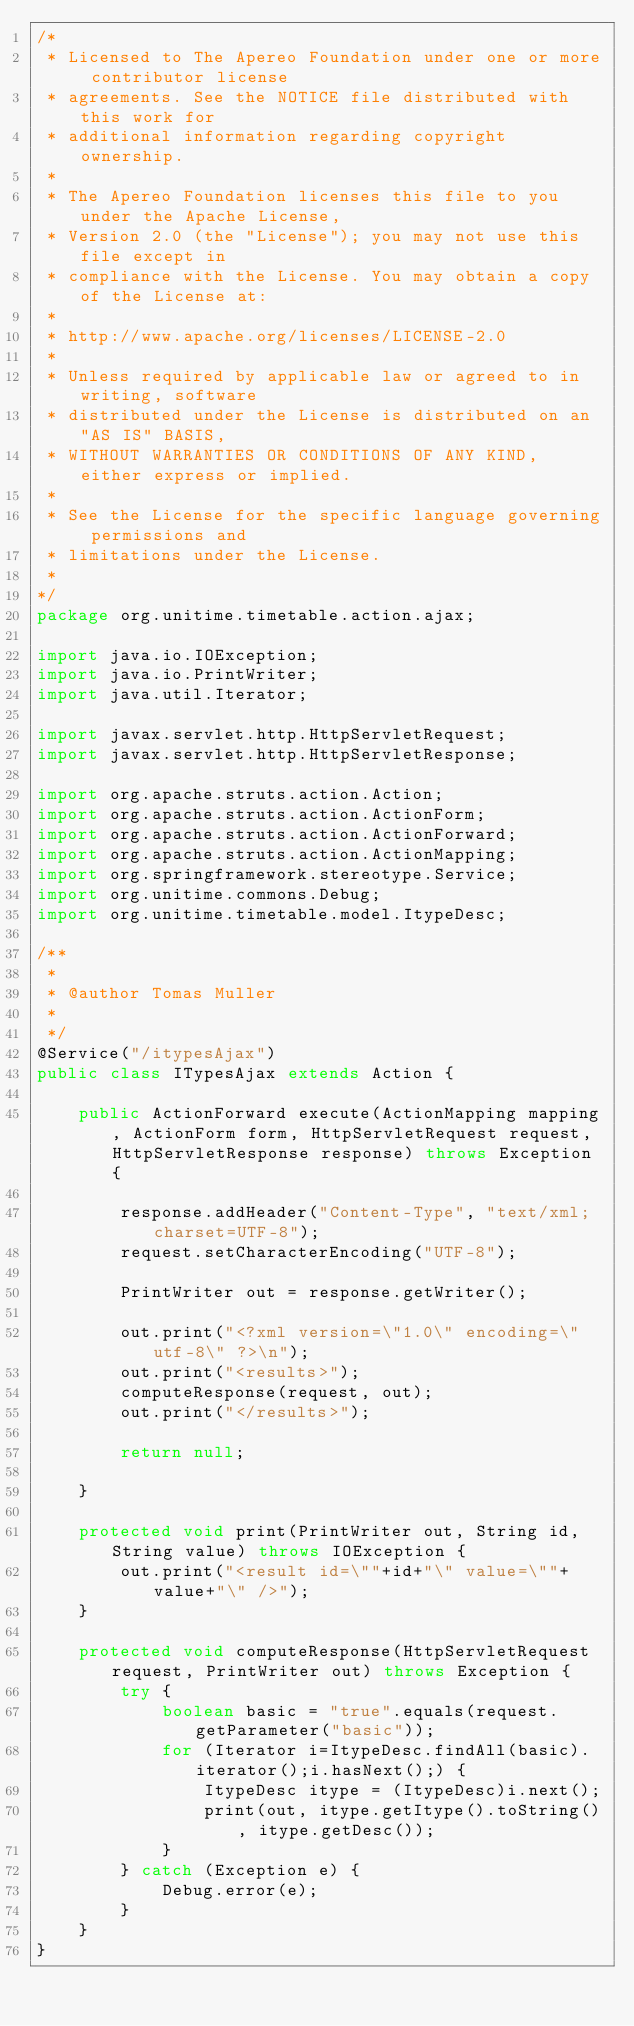Convert code to text. <code><loc_0><loc_0><loc_500><loc_500><_Java_>/*
 * Licensed to The Apereo Foundation under one or more contributor license
 * agreements. See the NOTICE file distributed with this work for
 * additional information regarding copyright ownership.
 *
 * The Apereo Foundation licenses this file to you under the Apache License,
 * Version 2.0 (the "License"); you may not use this file except in
 * compliance with the License. You may obtain a copy of the License at:
 *
 * http://www.apache.org/licenses/LICENSE-2.0
 *
 * Unless required by applicable law or agreed to in writing, software
 * distributed under the License is distributed on an "AS IS" BASIS,
 * WITHOUT WARRANTIES OR CONDITIONS OF ANY KIND, either express or implied.
 *
 * See the License for the specific language governing permissions and
 * limitations under the License.
 * 
*/
package org.unitime.timetable.action.ajax;

import java.io.IOException;
import java.io.PrintWriter;
import java.util.Iterator;

import javax.servlet.http.HttpServletRequest;
import javax.servlet.http.HttpServletResponse;

import org.apache.struts.action.Action;
import org.apache.struts.action.ActionForm;
import org.apache.struts.action.ActionForward;
import org.apache.struts.action.ActionMapping;
import org.springframework.stereotype.Service;
import org.unitime.commons.Debug;
import org.unitime.timetable.model.ItypeDesc;

/**
 * 
 * @author Tomas Muller
 *
 */
@Service("/itypesAjax")
public class ITypesAjax extends Action {

    public ActionForward execute(ActionMapping mapping, ActionForm form, HttpServletRequest request, HttpServletResponse response) throws Exception {
        
        response.addHeader("Content-Type", "text/xml; charset=UTF-8");
        request.setCharacterEncoding("UTF-8");
        
        PrintWriter out = response.getWriter();
        
        out.print("<?xml version=\"1.0\" encoding=\"utf-8\" ?>\n");
        out.print("<results>");
        computeResponse(request, out);
        out.print("</results>");
        
        return null;        

    }
    
    protected void print(PrintWriter out, String id, String value) throws IOException {
        out.print("<result id=\""+id+"\" value=\""+value+"\" />");
    }
    
    protected void computeResponse(HttpServletRequest request, PrintWriter out) throws Exception {
        try {
            boolean basic = "true".equals(request.getParameter("basic"));
            for (Iterator i=ItypeDesc.findAll(basic).iterator();i.hasNext();) {
                ItypeDesc itype = (ItypeDesc)i.next();
                print(out, itype.getItype().toString(), itype.getDesc());
            }
        } catch (Exception e) {
            Debug.error(e);
        }
    }
}
</code> 